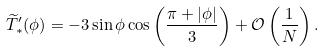<formula> <loc_0><loc_0><loc_500><loc_500>\widetilde { T } _ { \ast } ^ { \prime } ( \phi ) = - 3 \sin \phi \cos \left ( \frac { \pi + | \phi | } { 3 } \right ) + \mathcal { O } \left ( \frac { 1 } { N } \right ) .</formula> 